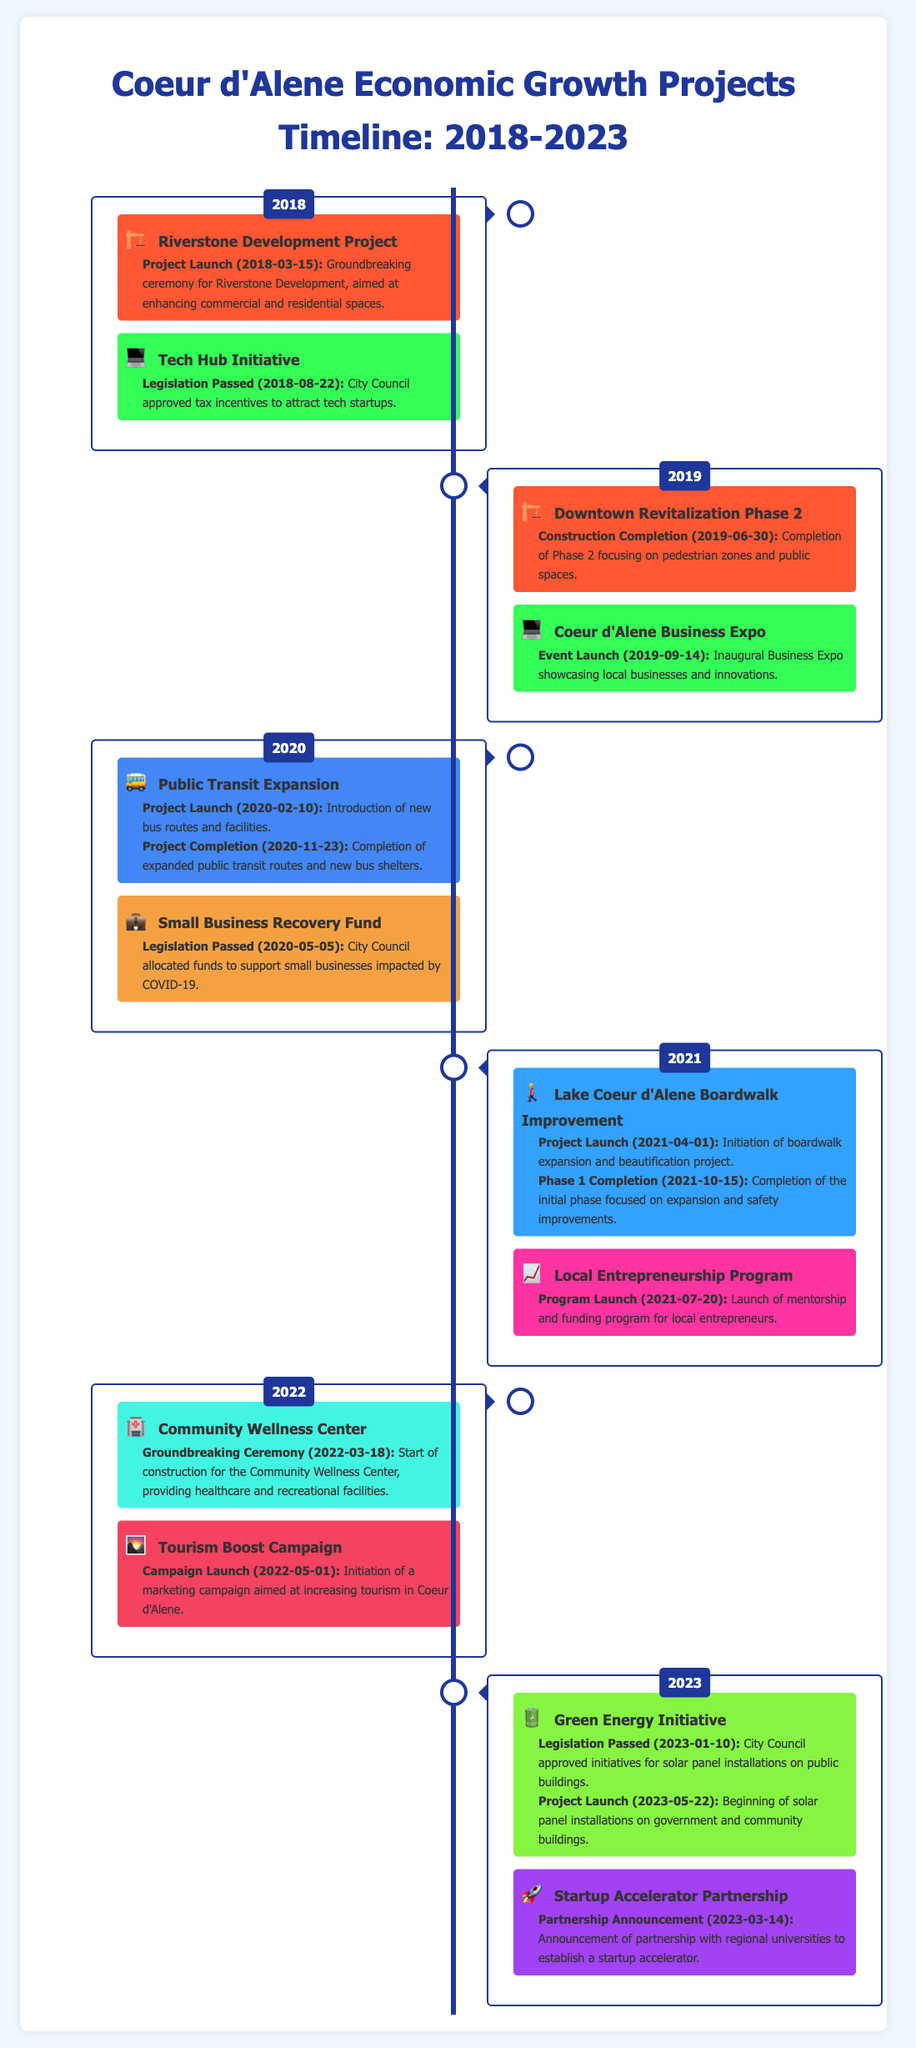What project was launched on March 15, 2018? The project launched on that date was the Riverstone Development Project.
Answer: Riverstone Development Project What type of initiative was approved on August 22, 2018? The initiative approved was related to tax incentives aimed at tech startups.
Answer: Tech Hub Initiative What was completed on June 30, 2019? The construction completion marked the end of Downtown Revitalization Phase 2.
Answer: Downtown Revitalization Phase 2 How many key milestones did the Public Transit Expansion project have? The Public Transit Expansion project had two key milestones: project launch and completion.
Answer: Two What initiative was launched on July 20, 2021? The initiative launched was the Local Entrepreneurship Program.
Answer: Local Entrepreneurship Program How many projects are highlighted in the year 2022? There are two projects highlighted for the year 2022: the Community Wellness Center and the Tourism Boost Campaign.
Answer: Two What significant event took place on May 1, 2022? The significant event was the launch of the Tourism Boost Campaign.
Answer: Campaign Launch What was the purpose of the Green Energy Initiative passed in 2023? The initiative aimed to approve solar panel installations on public buildings.
Answer: Solar panel installations Which project focused on small business recovery in 2020? The initiative focusing on small business recovery was the Small Business Recovery Fund.
Answer: Small Business Recovery Fund 